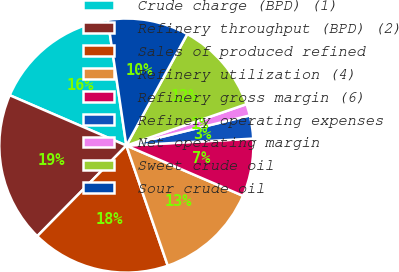<chart> <loc_0><loc_0><loc_500><loc_500><pie_chart><fcel>Crude charge (BPD) (1)<fcel>Refinery throughput (BPD) (2)<fcel>Sales of produced refined<fcel>Refinery utilization (4)<fcel>Refinery gross margin (6)<fcel>Refinery operating expenses<fcel>Net operating margin<fcel>Sweet crude oil<fcel>Sour crude oil<nl><fcel>16.18%<fcel>19.12%<fcel>17.65%<fcel>13.24%<fcel>7.35%<fcel>2.94%<fcel>1.47%<fcel>11.76%<fcel>10.29%<nl></chart> 